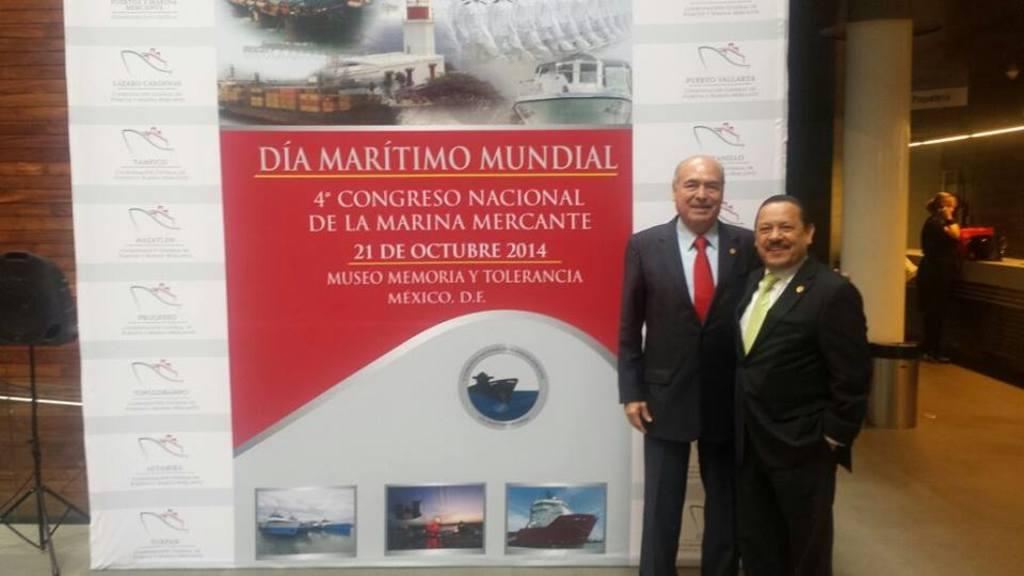What is the main subject of the image? The main subject of the image is the persons standing on the floor. What can be seen in the background of the image? There is a wall, a banner, and a stand in the background. Are there any objects or structures at the side of the image? Yes, there is a box and a pillar at the side. What type of hat can be seen on the persons in the image? There is no hat visible on the persons in the image. How many cakes are being served on the carriage in the image? There is no carriage or cakes present in the image. 